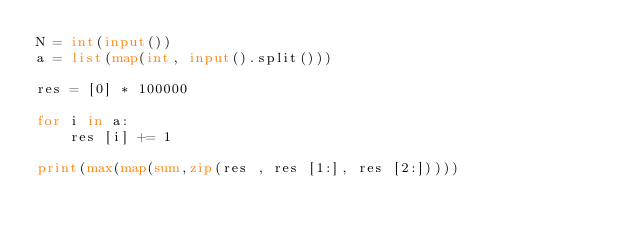<code> <loc_0><loc_0><loc_500><loc_500><_Python_>N = int(input())
a = list(map(int, input().split()))
 
res = [0] * 100000
 
for i in a:
	res [i] += 1
	
print(max(map(sum,zip(res , res [1:], res [2:]))))</code> 